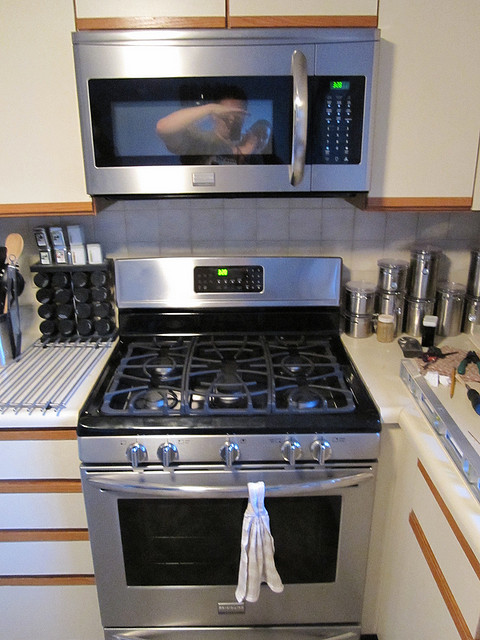What time is showing on the microwave clock? The microwave clock displays the time as 10:09. 